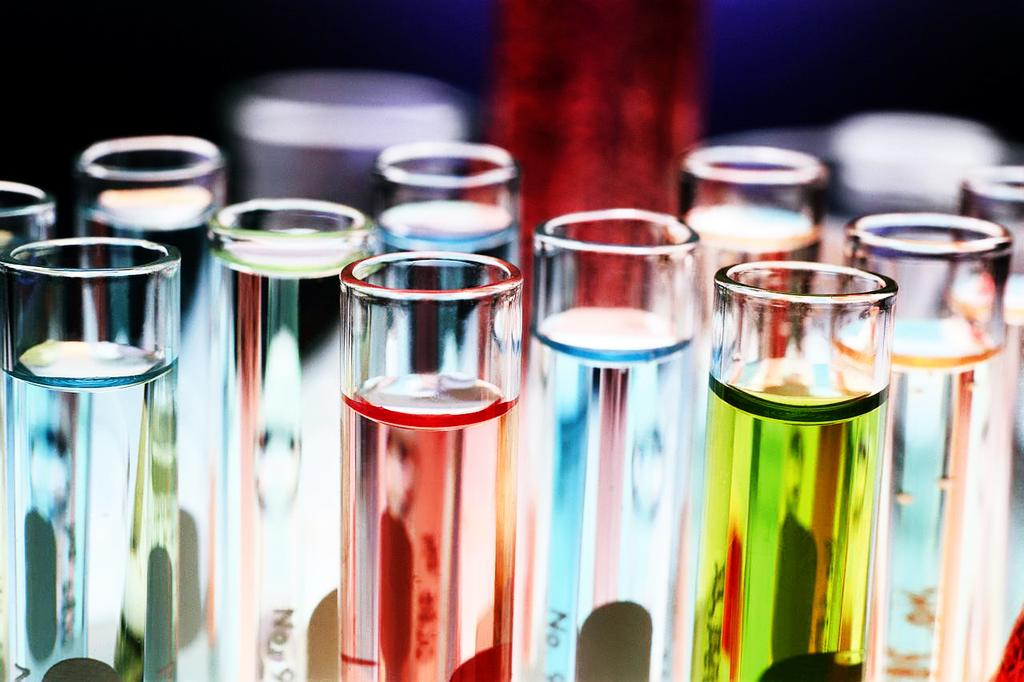<image>
Summarize the visual content of the image. the word no is on the glass with liquid inside 